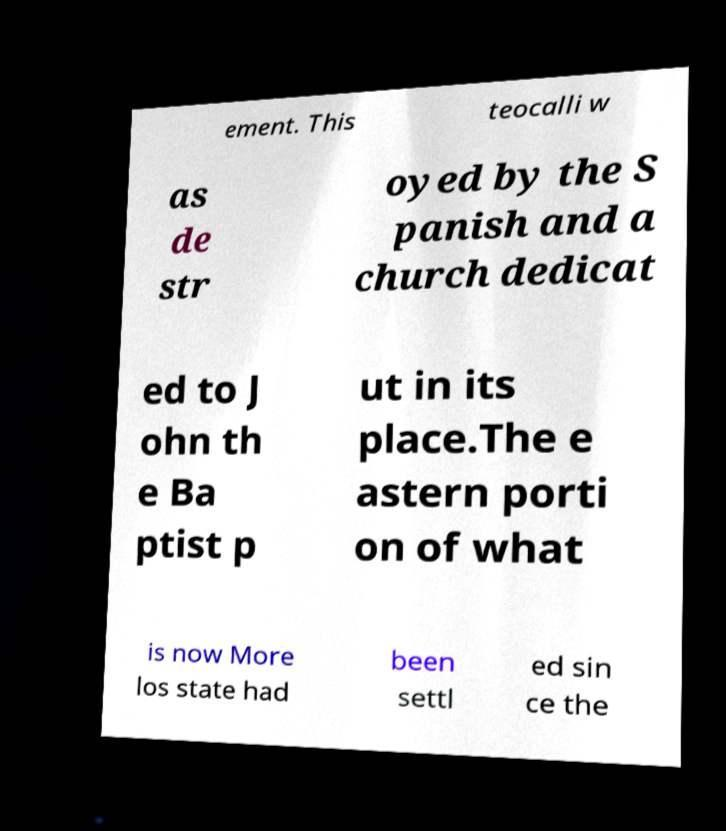Can you read and provide the text displayed in the image?This photo seems to have some interesting text. Can you extract and type it out for me? ement. This teocalli w as de str oyed by the S panish and a church dedicat ed to J ohn th e Ba ptist p ut in its place.The e astern porti on of what is now More los state had been settl ed sin ce the 